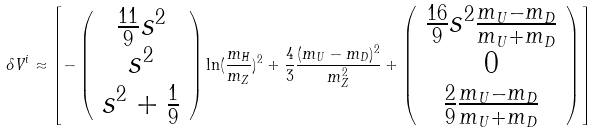Convert formula to latex. <formula><loc_0><loc_0><loc_500><loc_500>\delta V ^ { i } \approx \left [ - \left ( \begin{array} { c } \frac { 1 1 } { 9 } s ^ { 2 } \\ s ^ { 2 } \\ s ^ { 2 } + \frac { 1 } { 9 } \end{array} \right ) \ln ( \frac { m _ { H } } { m _ { Z } } ) ^ { 2 } + \frac { 4 } { 3 } \frac { ( m _ { U } - m _ { D } ) ^ { 2 } } { m _ { Z } ^ { 2 } } + \left ( \begin{array} { c } \frac { 1 6 } { 9 } s ^ { 2 } \frac { m _ { U } - m _ { D } } { m _ { U } + m _ { D } } \\ 0 \\ \frac { 2 } { 9 } \frac { m _ { U } - m _ { D } } { m _ { U } + m _ { D } } \end{array} \right ) \right ]</formula> 